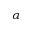Convert formula to latex. <formula><loc_0><loc_0><loc_500><loc_500>\alpha</formula> 